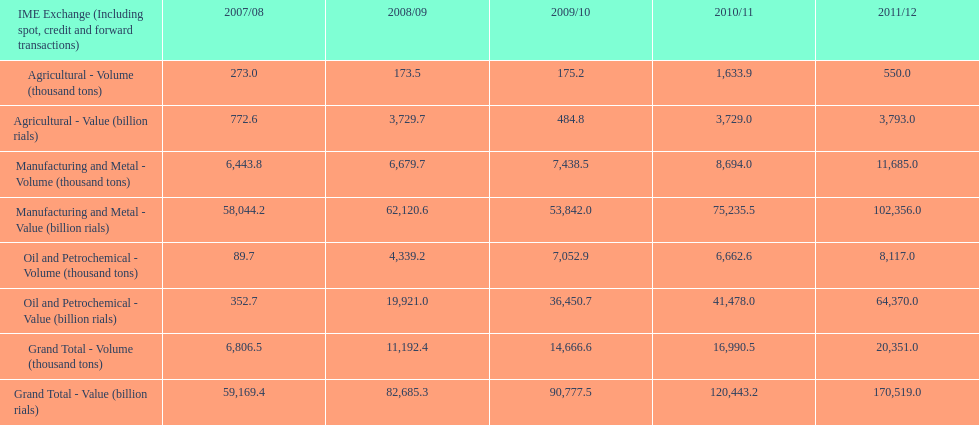Parse the full table. {'header': ['IME Exchange (Including spot, credit and forward transactions)', '2007/08', '2008/09', '2009/10', '2010/11', '2011/12'], 'rows': [['Agricultural - Volume (thousand tons)', '273.0', '173.5', '175.2', '1,633.9', '550.0'], ['Agricultural - Value (billion rials)', '772.6', '3,729.7', '484.8', '3,729.0', '3,793.0'], ['Manufacturing and Metal - Volume (thousand tons)', '6,443.8', '6,679.7', '7,438.5', '8,694.0', '11,685.0'], ['Manufacturing and Metal - Value (billion rials)', '58,044.2', '62,120.6', '53,842.0', '75,235.5', '102,356.0'], ['Oil and Petrochemical - Volume (thousand tons)', '89.7', '4,339.2', '7,052.9', '6,662.6', '8,117.0'], ['Oil and Petrochemical - Value (billion rials)', '352.7', '19,921.0', '36,450.7', '41,478.0', '64,370.0'], ['Grand Total - Volume (thousand tons)', '6,806.5', '11,192.4', '14,666.6', '16,990.5', '20,351.0'], ['Grand Total - Value (billion rials)', '59,169.4', '82,685.3', '90,777.5', '120,443.2', '170,519.0']]} Was the grand total value greater in 2010/11 or 2011/12? 2011/12. 